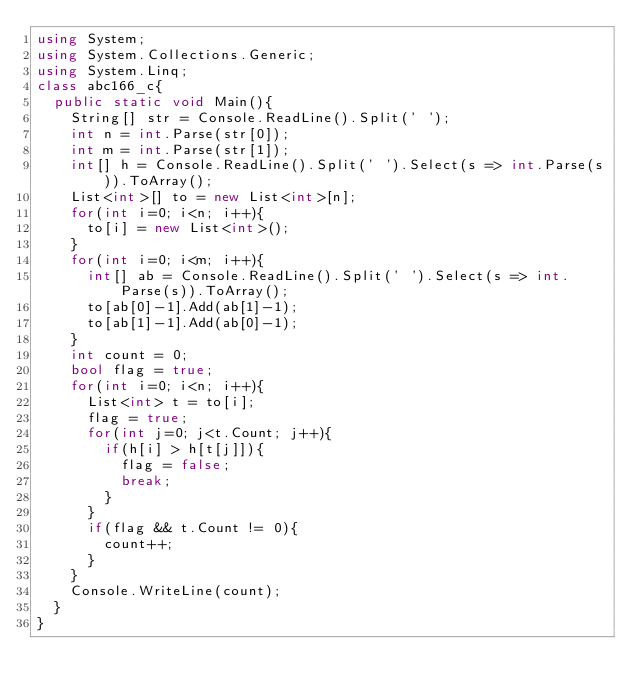Convert code to text. <code><loc_0><loc_0><loc_500><loc_500><_C#_>using System;
using System.Collections.Generic;
using System.Linq;
class abc166_c{
  public static void Main(){
    String[] str = Console.ReadLine().Split(' ');
    int n = int.Parse(str[0]);
    int m = int.Parse(str[1]);
    int[] h = Console.ReadLine().Split(' ').Select(s => int.Parse(s)).ToArray();
    List<int>[] to = new List<int>[n];
    for(int i=0; i<n; i++){
      to[i] = new List<int>();
    }
    for(int i=0; i<m; i++){
      int[] ab = Console.ReadLine().Split(' ').Select(s => int.Parse(s)).ToArray();
      to[ab[0]-1].Add(ab[1]-1);
      to[ab[1]-1].Add(ab[0]-1);
    }
    int count = 0;
    bool flag = true;
    for(int i=0; i<n; i++){
      List<int> t = to[i];
      flag = true;
      for(int j=0; j<t.Count; j++){
        if(h[i] > h[t[j]]){
          flag = false;
          break;
        }
      }
      if(flag && t.Count != 0){
        count++;
      }
    }
    Console.WriteLine(count);
  }
}
</code> 